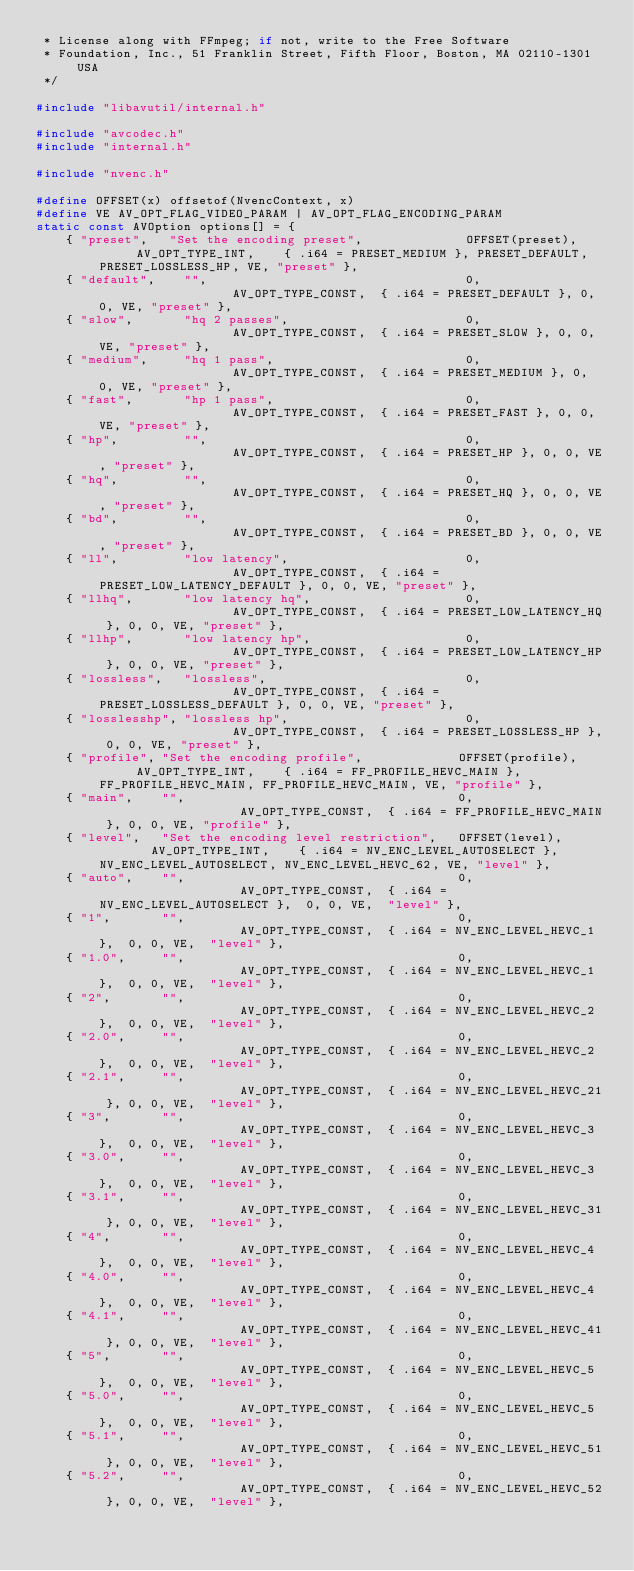<code> <loc_0><loc_0><loc_500><loc_500><_C_> * License along with FFmpeg; if not, write to the Free Software
 * Foundation, Inc., 51 Franklin Street, Fifth Floor, Boston, MA 02110-1301 USA
 */

#include "libavutil/internal.h"

#include "avcodec.h"
#include "internal.h"

#include "nvenc.h"

#define OFFSET(x) offsetof(NvencContext, x)
#define VE AV_OPT_FLAG_VIDEO_PARAM | AV_OPT_FLAG_ENCODING_PARAM
static const AVOption options[] = {
    { "preset",   "Set the encoding preset",              OFFSET(preset),      AV_OPT_TYPE_INT,    { .i64 = PRESET_MEDIUM }, PRESET_DEFAULT, PRESET_LOSSLESS_HP, VE, "preset" },
    { "default",    "",                                   0,                   AV_OPT_TYPE_CONST,  { .i64 = PRESET_DEFAULT }, 0, 0, VE, "preset" },
    { "slow",       "hq 2 passes",                        0,                   AV_OPT_TYPE_CONST,  { .i64 = PRESET_SLOW }, 0, 0, VE, "preset" },
    { "medium",     "hq 1 pass",                          0,                   AV_OPT_TYPE_CONST,  { .i64 = PRESET_MEDIUM }, 0, 0, VE, "preset" },
    { "fast",       "hp 1 pass",                          0,                   AV_OPT_TYPE_CONST,  { .i64 = PRESET_FAST }, 0, 0, VE, "preset" },
    { "hp",         "",                                   0,                   AV_OPT_TYPE_CONST,  { .i64 = PRESET_HP }, 0, 0, VE, "preset" },
    { "hq",         "",                                   0,                   AV_OPT_TYPE_CONST,  { .i64 = PRESET_HQ }, 0, 0, VE, "preset" },
    { "bd",         "",                                   0,                   AV_OPT_TYPE_CONST,  { .i64 = PRESET_BD }, 0, 0, VE, "preset" },
    { "ll",         "low latency",                        0,                   AV_OPT_TYPE_CONST,  { .i64 = PRESET_LOW_LATENCY_DEFAULT }, 0, 0, VE, "preset" },
    { "llhq",       "low latency hq",                     0,                   AV_OPT_TYPE_CONST,  { .i64 = PRESET_LOW_LATENCY_HQ }, 0, 0, VE, "preset" },
    { "llhp",       "low latency hp",                     0,                   AV_OPT_TYPE_CONST,  { .i64 = PRESET_LOW_LATENCY_HP }, 0, 0, VE, "preset" },
    { "lossless",   "lossless",                           0,                   AV_OPT_TYPE_CONST,  { .i64 = PRESET_LOSSLESS_DEFAULT }, 0, 0, VE, "preset" },
    { "losslesshp", "lossless hp",                        0,                   AV_OPT_TYPE_CONST,  { .i64 = PRESET_LOSSLESS_HP }, 0, 0, VE, "preset" },
    { "profile", "Set the encoding profile",             OFFSET(profile),      AV_OPT_TYPE_INT,    { .i64 = FF_PROFILE_HEVC_MAIN }, FF_PROFILE_HEVC_MAIN, FF_PROFILE_HEVC_MAIN, VE, "profile" },
    { "main",    "",                                     0,                    AV_OPT_TYPE_CONST,  { .i64 = FF_PROFILE_HEVC_MAIN }, 0, 0, VE, "profile" },
    { "level",   "Set the encoding level restriction",   OFFSET(level),        AV_OPT_TYPE_INT,    { .i64 = NV_ENC_LEVEL_AUTOSELECT }, NV_ENC_LEVEL_AUTOSELECT, NV_ENC_LEVEL_HEVC_62, VE, "level" },
    { "auto",    "",                                     0,                    AV_OPT_TYPE_CONST,  { .i64 = NV_ENC_LEVEL_AUTOSELECT },  0, 0, VE,  "level" },
    { "1",       "",                                     0,                    AV_OPT_TYPE_CONST,  { .i64 = NV_ENC_LEVEL_HEVC_1 },  0, 0, VE,  "level" },
    { "1.0",     "",                                     0,                    AV_OPT_TYPE_CONST,  { .i64 = NV_ENC_LEVEL_HEVC_1 },  0, 0, VE,  "level" },
    { "2",       "",                                     0,                    AV_OPT_TYPE_CONST,  { .i64 = NV_ENC_LEVEL_HEVC_2 },  0, 0, VE,  "level" },
    { "2.0",     "",                                     0,                    AV_OPT_TYPE_CONST,  { .i64 = NV_ENC_LEVEL_HEVC_2 },  0, 0, VE,  "level" },
    { "2.1",     "",                                     0,                    AV_OPT_TYPE_CONST,  { .i64 = NV_ENC_LEVEL_HEVC_21 }, 0, 0, VE,  "level" },
    { "3",       "",                                     0,                    AV_OPT_TYPE_CONST,  { .i64 = NV_ENC_LEVEL_HEVC_3 },  0, 0, VE,  "level" },
    { "3.0",     "",                                     0,                    AV_OPT_TYPE_CONST,  { .i64 = NV_ENC_LEVEL_HEVC_3 },  0, 0, VE,  "level" },
    { "3.1",     "",                                     0,                    AV_OPT_TYPE_CONST,  { .i64 = NV_ENC_LEVEL_HEVC_31 }, 0, 0, VE,  "level" },
    { "4",       "",                                     0,                    AV_OPT_TYPE_CONST,  { .i64 = NV_ENC_LEVEL_HEVC_4 },  0, 0, VE,  "level" },
    { "4.0",     "",                                     0,                    AV_OPT_TYPE_CONST,  { .i64 = NV_ENC_LEVEL_HEVC_4 },  0, 0, VE,  "level" },
    { "4.1",     "",                                     0,                    AV_OPT_TYPE_CONST,  { .i64 = NV_ENC_LEVEL_HEVC_41 }, 0, 0, VE,  "level" },
    { "5",       "",                                     0,                    AV_OPT_TYPE_CONST,  { .i64 = NV_ENC_LEVEL_HEVC_5 },  0, 0, VE,  "level" },
    { "5.0",     "",                                     0,                    AV_OPT_TYPE_CONST,  { .i64 = NV_ENC_LEVEL_HEVC_5 },  0, 0, VE,  "level" },
    { "5.1",     "",                                     0,                    AV_OPT_TYPE_CONST,  { .i64 = NV_ENC_LEVEL_HEVC_51 }, 0, 0, VE,  "level" },
    { "5.2",     "",                                     0,                    AV_OPT_TYPE_CONST,  { .i64 = NV_ENC_LEVEL_HEVC_52 }, 0, 0, VE,  "level" },</code> 